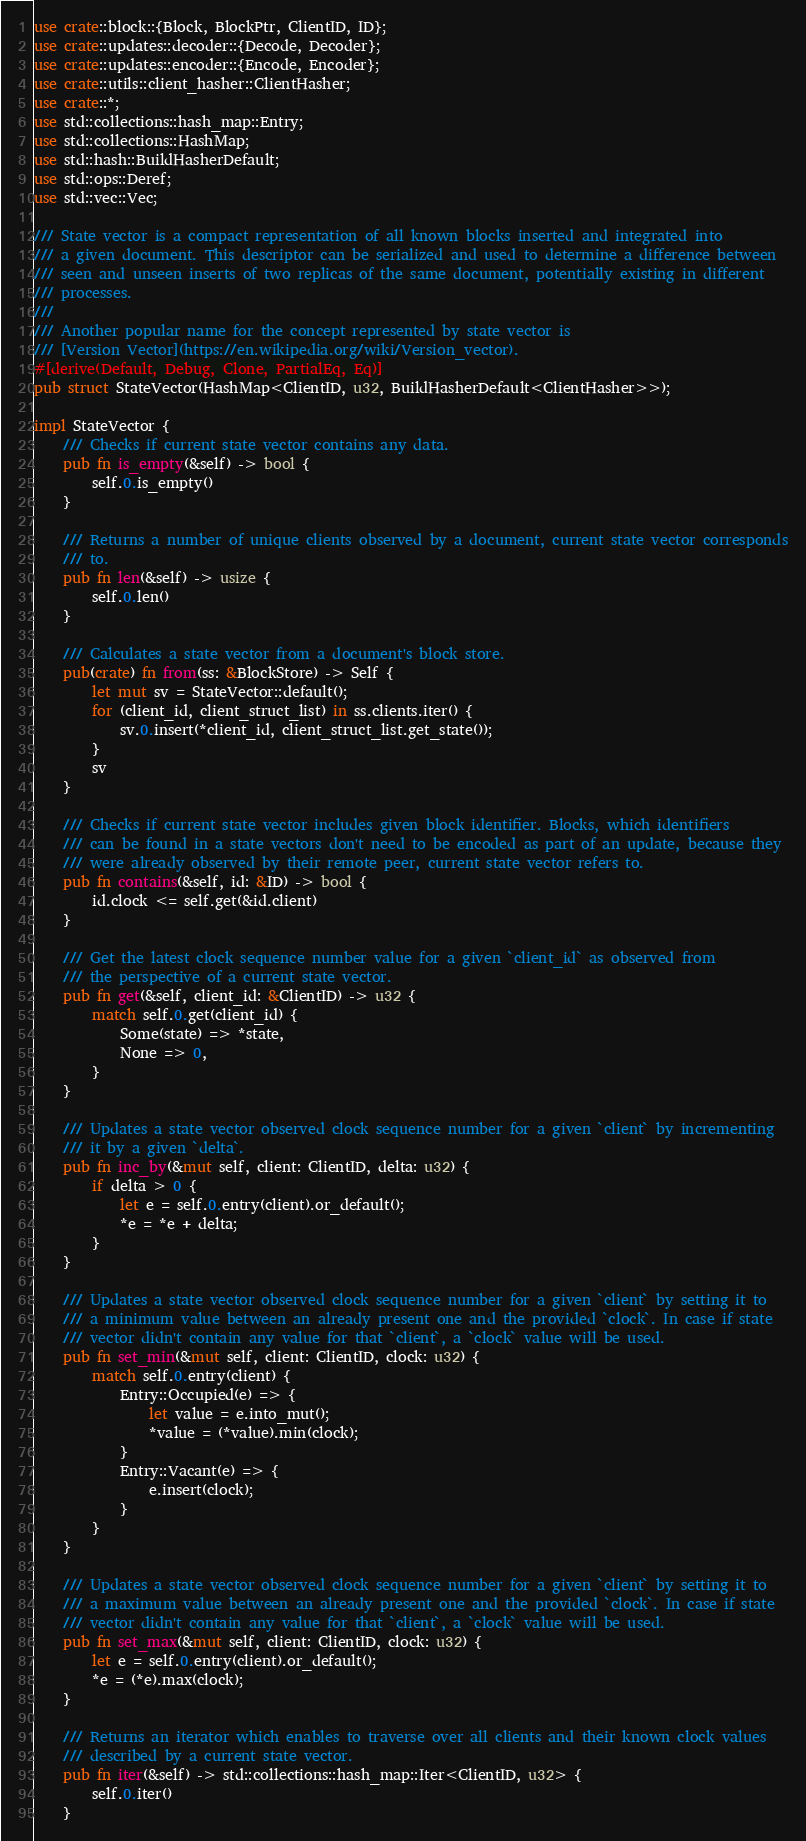<code> <loc_0><loc_0><loc_500><loc_500><_Rust_>use crate::block::{Block, BlockPtr, ClientID, ID};
use crate::updates::decoder::{Decode, Decoder};
use crate::updates::encoder::{Encode, Encoder};
use crate::utils::client_hasher::ClientHasher;
use crate::*;
use std::collections::hash_map::Entry;
use std::collections::HashMap;
use std::hash::BuildHasherDefault;
use std::ops::Deref;
use std::vec::Vec;

/// State vector is a compact representation of all known blocks inserted and integrated into
/// a given document. This descriptor can be serialized and used to determine a difference between
/// seen and unseen inserts of two replicas of the same document, potentially existing in different
/// processes.
///
/// Another popular name for the concept represented by state vector is
/// [Version Vector](https://en.wikipedia.org/wiki/Version_vector).
#[derive(Default, Debug, Clone, PartialEq, Eq)]
pub struct StateVector(HashMap<ClientID, u32, BuildHasherDefault<ClientHasher>>);

impl StateVector {
    /// Checks if current state vector contains any data.
    pub fn is_empty(&self) -> bool {
        self.0.is_empty()
    }

    /// Returns a number of unique clients observed by a document, current state vector corresponds
    /// to.
    pub fn len(&self) -> usize {
        self.0.len()
    }

    /// Calculates a state vector from a document's block store.
    pub(crate) fn from(ss: &BlockStore) -> Self {
        let mut sv = StateVector::default();
        for (client_id, client_struct_list) in ss.clients.iter() {
            sv.0.insert(*client_id, client_struct_list.get_state());
        }
        sv
    }

    /// Checks if current state vector includes given block identifier. Blocks, which identifiers
    /// can be found in a state vectors don't need to be encoded as part of an update, because they
    /// were already observed by their remote peer, current state vector refers to.
    pub fn contains(&self, id: &ID) -> bool {
        id.clock <= self.get(&id.client)
    }

    /// Get the latest clock sequence number value for a given `client_id` as observed from
    /// the perspective of a current state vector.
    pub fn get(&self, client_id: &ClientID) -> u32 {
        match self.0.get(client_id) {
            Some(state) => *state,
            None => 0,
        }
    }

    /// Updates a state vector observed clock sequence number for a given `client` by incrementing
    /// it by a given `delta`.
    pub fn inc_by(&mut self, client: ClientID, delta: u32) {
        if delta > 0 {
            let e = self.0.entry(client).or_default();
            *e = *e + delta;
        }
    }

    /// Updates a state vector observed clock sequence number for a given `client` by setting it to
    /// a minimum value between an already present one and the provided `clock`. In case if state
    /// vector didn't contain any value for that `client`, a `clock` value will be used.
    pub fn set_min(&mut self, client: ClientID, clock: u32) {
        match self.0.entry(client) {
            Entry::Occupied(e) => {
                let value = e.into_mut();
                *value = (*value).min(clock);
            }
            Entry::Vacant(e) => {
                e.insert(clock);
            }
        }
    }

    /// Updates a state vector observed clock sequence number for a given `client` by setting it to
    /// a maximum value between an already present one and the provided `clock`. In case if state
    /// vector didn't contain any value for that `client`, a `clock` value will be used.
    pub fn set_max(&mut self, client: ClientID, clock: u32) {
        let e = self.0.entry(client).or_default();
        *e = (*e).max(clock);
    }

    /// Returns an iterator which enables to traverse over all clients and their known clock values
    /// described by a current state vector.
    pub fn iter(&self) -> std::collections::hash_map::Iter<ClientID, u32> {
        self.0.iter()
    }
</code> 